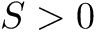<formula> <loc_0><loc_0><loc_500><loc_500>S > 0</formula> 